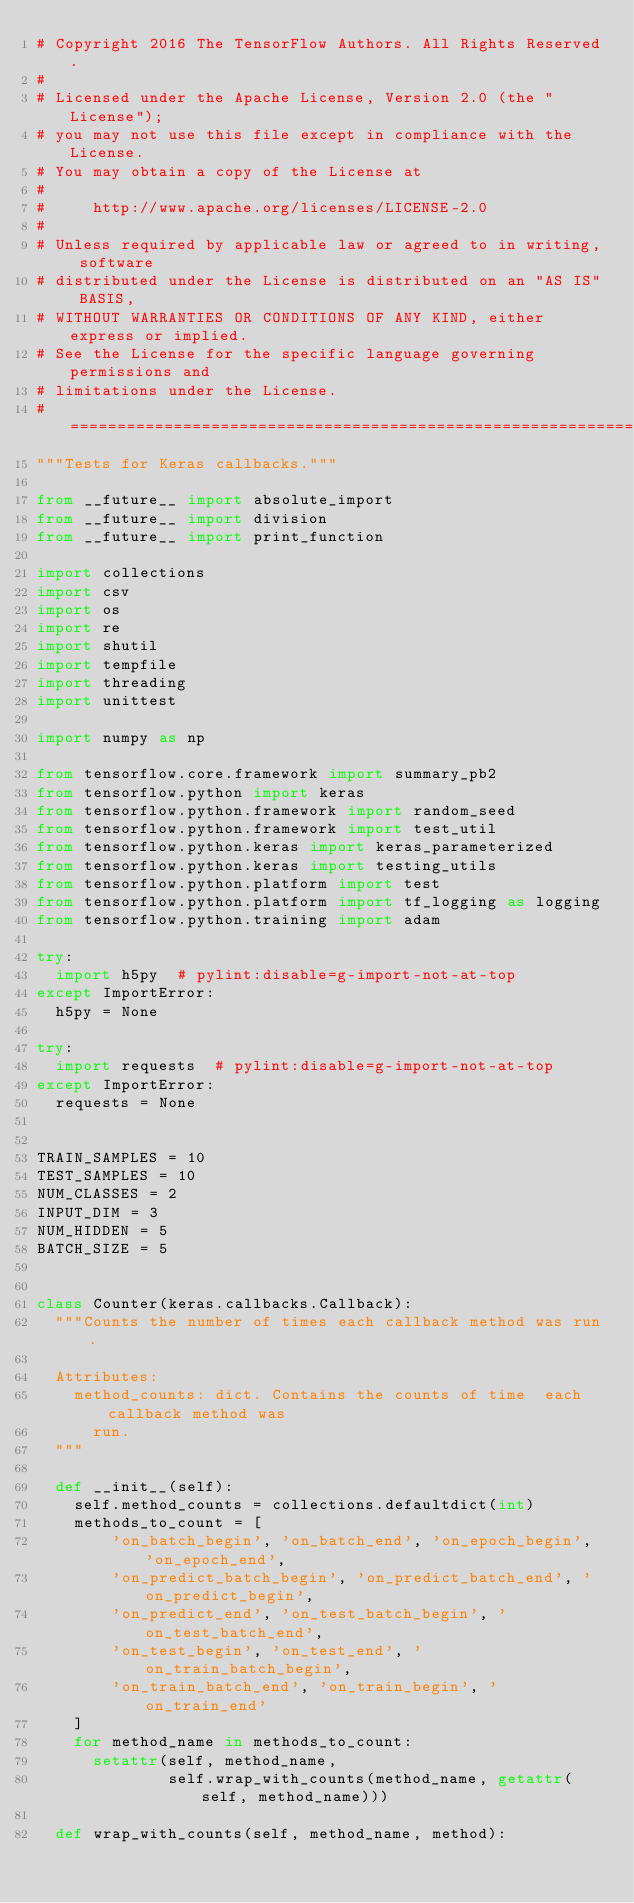Convert code to text. <code><loc_0><loc_0><loc_500><loc_500><_Python_># Copyright 2016 The TensorFlow Authors. All Rights Reserved.
#
# Licensed under the Apache License, Version 2.0 (the "License");
# you may not use this file except in compliance with the License.
# You may obtain a copy of the License at
#
#     http://www.apache.org/licenses/LICENSE-2.0
#
# Unless required by applicable law or agreed to in writing, software
# distributed under the License is distributed on an "AS IS" BASIS,
# WITHOUT WARRANTIES OR CONDITIONS OF ANY KIND, either express or implied.
# See the License for the specific language governing permissions and
# limitations under the License.
# ==============================================================================
"""Tests for Keras callbacks."""

from __future__ import absolute_import
from __future__ import division
from __future__ import print_function

import collections
import csv
import os
import re
import shutil
import tempfile
import threading
import unittest

import numpy as np

from tensorflow.core.framework import summary_pb2
from tensorflow.python import keras
from tensorflow.python.framework import random_seed
from tensorflow.python.framework import test_util
from tensorflow.python.keras import keras_parameterized
from tensorflow.python.keras import testing_utils
from tensorflow.python.platform import test
from tensorflow.python.platform import tf_logging as logging
from tensorflow.python.training import adam

try:
  import h5py  # pylint:disable=g-import-not-at-top
except ImportError:
  h5py = None

try:
  import requests  # pylint:disable=g-import-not-at-top
except ImportError:
  requests = None


TRAIN_SAMPLES = 10
TEST_SAMPLES = 10
NUM_CLASSES = 2
INPUT_DIM = 3
NUM_HIDDEN = 5
BATCH_SIZE = 5


class Counter(keras.callbacks.Callback):
  """Counts the number of times each callback method was run.

  Attributes:
    method_counts: dict. Contains the counts of time  each callback method was
      run.
  """

  def __init__(self):
    self.method_counts = collections.defaultdict(int)
    methods_to_count = [
        'on_batch_begin', 'on_batch_end', 'on_epoch_begin', 'on_epoch_end',
        'on_predict_batch_begin', 'on_predict_batch_end', 'on_predict_begin',
        'on_predict_end', 'on_test_batch_begin', 'on_test_batch_end',
        'on_test_begin', 'on_test_end', 'on_train_batch_begin',
        'on_train_batch_end', 'on_train_begin', 'on_train_end'
    ]
    for method_name in methods_to_count:
      setattr(self, method_name,
              self.wrap_with_counts(method_name, getattr(self, method_name)))

  def wrap_with_counts(self, method_name, method):
</code> 